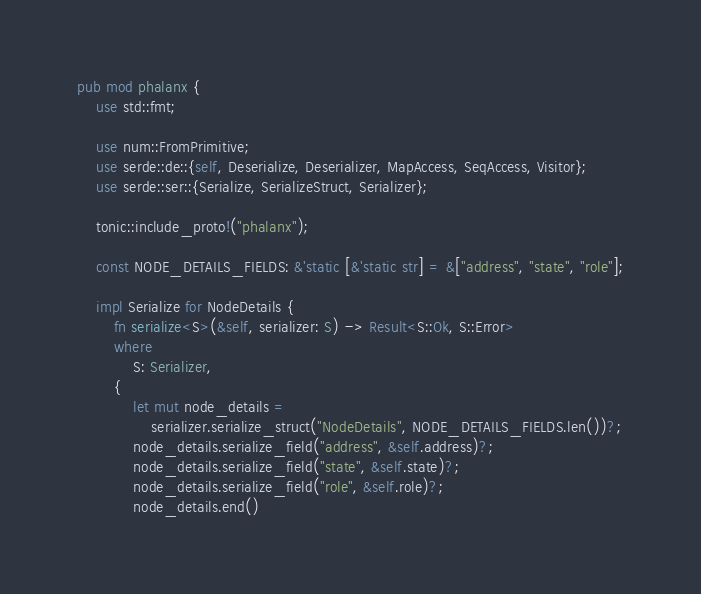Convert code to text. <code><loc_0><loc_0><loc_500><loc_500><_Rust_>pub mod phalanx {
    use std::fmt;

    use num::FromPrimitive;
    use serde::de::{self, Deserialize, Deserializer, MapAccess, SeqAccess, Visitor};
    use serde::ser::{Serialize, SerializeStruct, Serializer};

    tonic::include_proto!("phalanx");

    const NODE_DETAILS_FIELDS: &'static [&'static str] = &["address", "state", "role"];

    impl Serialize for NodeDetails {
        fn serialize<S>(&self, serializer: S) -> Result<S::Ok, S::Error>
        where
            S: Serializer,
        {
            let mut node_details =
                serializer.serialize_struct("NodeDetails", NODE_DETAILS_FIELDS.len())?;
            node_details.serialize_field("address", &self.address)?;
            node_details.serialize_field("state", &self.state)?;
            node_details.serialize_field("role", &self.role)?;
            node_details.end()</code> 